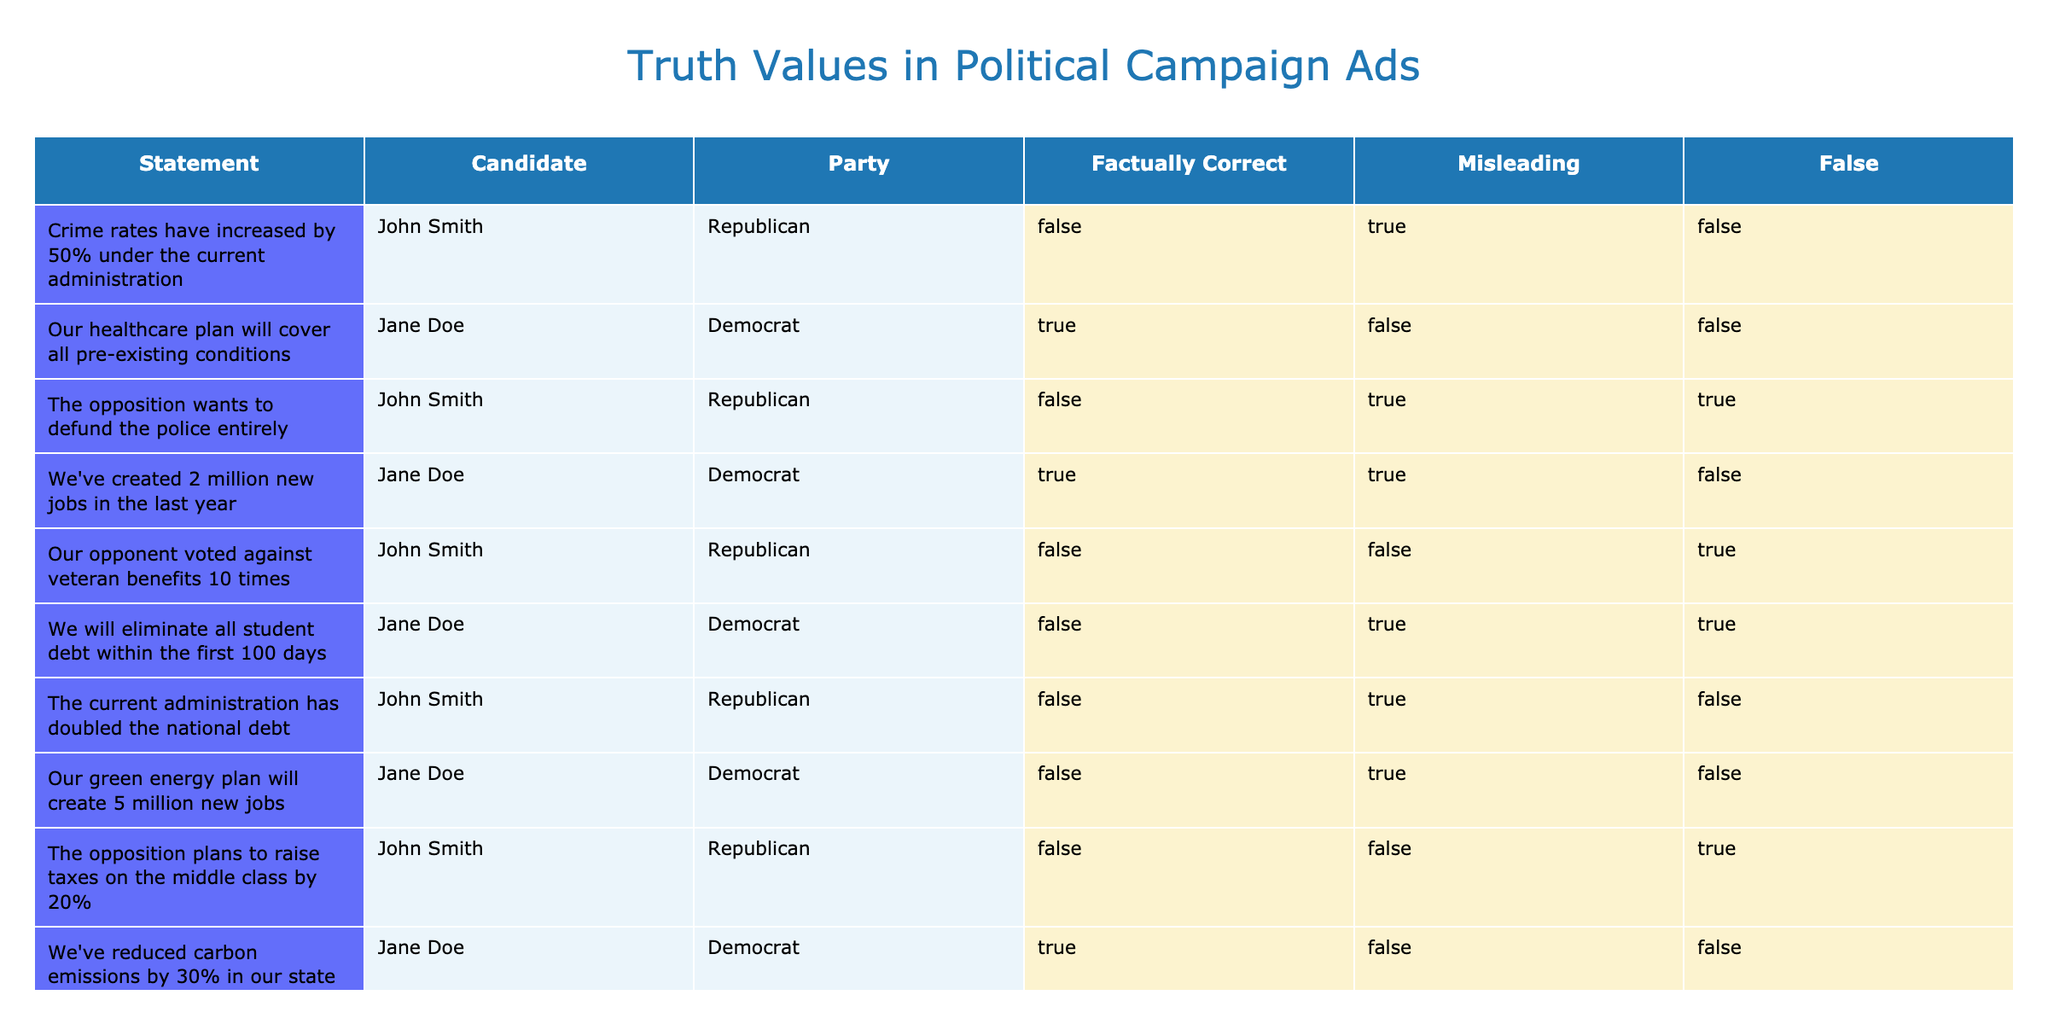What is the factually correct statement made by Jane Doe? The table indicates that Jane Doe's statement "Our healthcare plan will cover all pre-existing conditions" is factually correct as it is marked TRUE in the 'Factually Correct' column.
Answer: Our healthcare plan will cover all pre-existing conditions How many statements made by John Smith are considered misleading? By reviewing the 'Misleading' column for John Smith, we see that he has two misleading statements: "Crime rates have increased by 50% under the current administration" and "The opposition wants to defund the police entirely". Therefore, the count is 2.
Answer: 2 Is it true that Jane Doe claimed to eliminate all student debt? The statement "We will eliminate all student debt within the first 100 days" is attributed to Jane Doe, and according to the table, it is marked FALSE in the 'Factually Correct' column, which confirms that this statement is not true.
Answer: Yes Which candidate made a statement regarding job creation that was misleading? Upon examining the statements, Jane Doe claimed "We've created 2 million new jobs in the last year." Although it is marked TRUE, it is also labeled as misleading. This indicates Jane Doe is the candidate who made a misleading claim about job creation.
Answer: Jane Doe What percentage of John Smith's statements are false? John Smith made 5 statements in total. Out of these, 2 are marked as false. To calculate the percentage of false statements: (2 false statements / 5 total statements) * 100 = 40%.
Answer: 40% Which candidate has the most factually correct statements? Comparing the 'Factually Correct' column, Jane Doe has 3 factually correct statements: "Our healthcare plan will cover all pre-existing conditions", "We've reduced carbon emissions by 30% in our state", and "We've created 2 million new jobs in the last year." John Smith has none, making Jane Doe the candidate with the most factually correct statements.
Answer: Jane Doe How many misleading statements did Jane Doe make? A review of Jane Doe's statements shows that only "We've created 2 million new jobs in the last year" is marked as misleading. Thus, Jane Doe made 1 misleading statement.
Answer: 1 Did any statements contain both misleading and false elements? The statement "The opposition wants to defund the police entirely" by John Smith is marked as both misleading and false, which indicates that at least one statement contains both traits.
Answer: Yes What is the total count of factually correct statements among all candidates? By counting the factually correct statements from both candidates, Jane Doe has 3, and John Smith has none, yielding a total of 3 factually correct statements altogether.
Answer: 3 